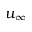<formula> <loc_0><loc_0><loc_500><loc_500>u _ { \infty }</formula> 